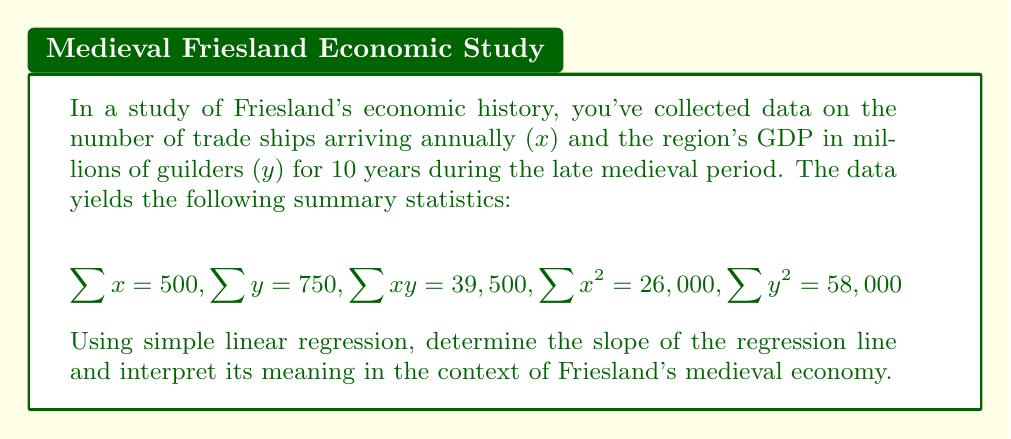Give your solution to this math problem. To find the slope of the regression line, we'll use the formula:

$$b = \frac{n\sum xy - \sum x \sum y}{n\sum x^2 - (\sum x)^2}$$

Where n is the number of data points (10 in this case).

Step 1: Calculate the numerator
$$n\sum xy - \sum x \sum y = 10(39,500) - 500(750) = 395,000 - 375,000 = 20,000$$

Step 2: Calculate the denominator
$$n\sum x^2 - (\sum x)^2 = 10(26,000) - 500^2 = 260,000 - 250,000 = 10,000$$

Step 3: Divide to find the slope
$$b = \frac{20,000}{10,000} = 2$$

Interpretation: The slope of 2 indicates that for each additional trade ship arriving annually in medieval Friesland, the region's GDP increased by an average of 2 million guilders. This demonstrates a positive economic impact of trade routes on Friesland's economy during the late medieval period.
Answer: Slope = 2; Each additional trade ship correlated with a 2 million guilder increase in GDP. 